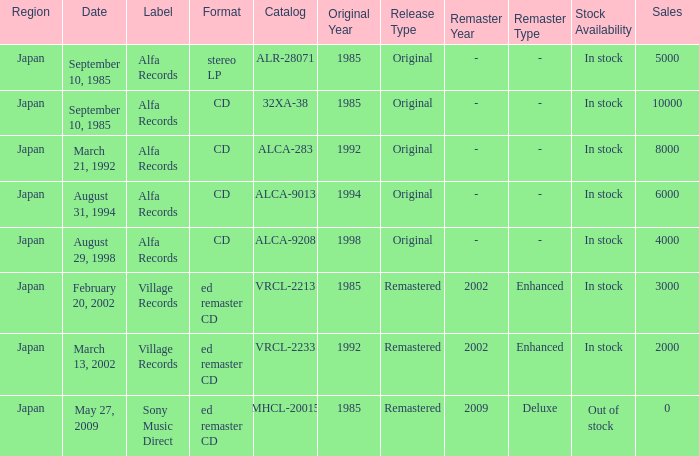Which Label was cataloged as alca-9013? Alfa Records. 